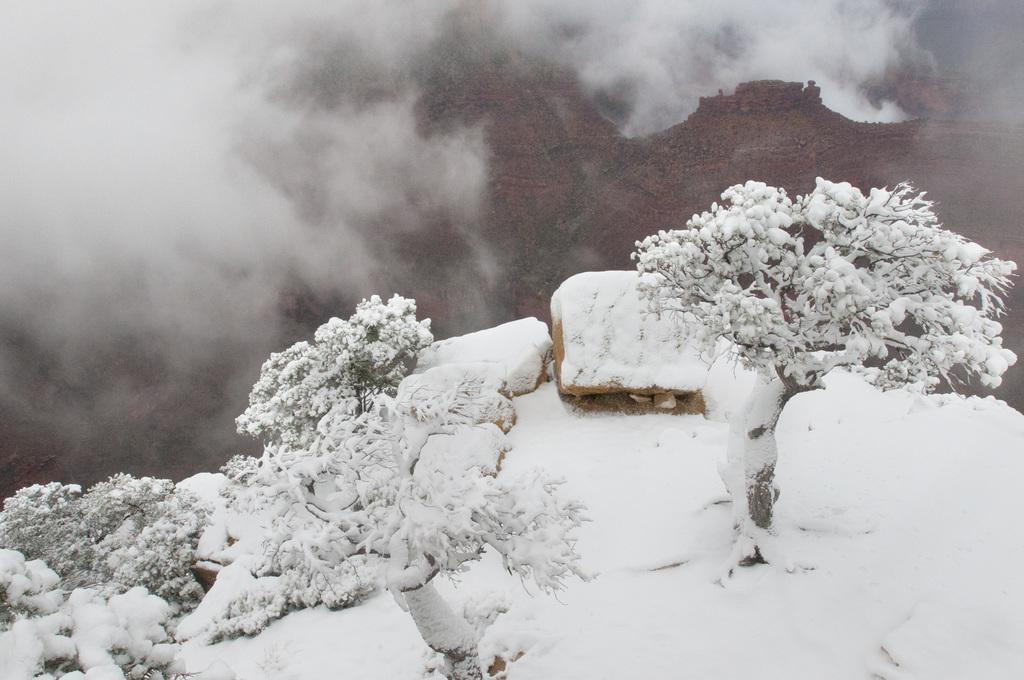What can be seen in the foreground of the picture? There are trees, plants, rocks, and snow in the foreground of the picture. What type of terrain is visible in the center of the background of the picture? There are hills in the center of the background of the picture. How would you describe the top of the image? The top of the image is foggy. What type of silk is being used to create the story in the image? There is no silk or story present in the image; it features a landscape with trees, plants, rocks, snow, hills, and fog. How many times does the person kick the ball in the image? There is no person or ball present in the image. 